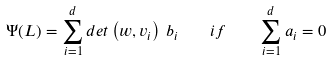Convert formula to latex. <formula><loc_0><loc_0><loc_500><loc_500>\Psi ( L ) = \sum _ { i = 1 } ^ { d } d e t \left ( w , v _ { i } \right ) \, b _ { i } \quad i f \quad \sum _ { i = 1 } ^ { d } a _ { i } = 0</formula> 